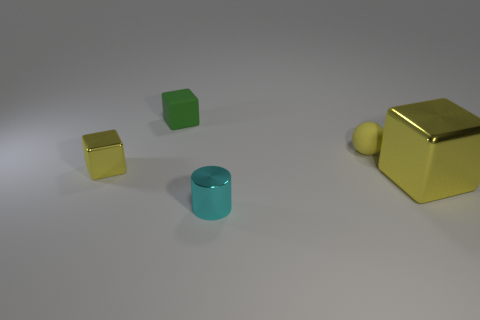Are there any small yellow balls behind the yellow sphere?
Your answer should be very brief. No. How many green objects are the same shape as the small yellow metallic thing?
Offer a very short reply. 1. There is a tiny metal thing left of the tiny object in front of the yellow shiny cube that is to the right of the green object; what is its color?
Your answer should be compact. Yellow. Does the small yellow object that is right of the small cyan shiny thing have the same material as the small block in front of the sphere?
Make the answer very short. No. What number of things are either objects behind the cylinder or tiny matte blocks?
Your answer should be very brief. 4. How many objects are tiny metallic objects or blocks that are to the right of the small shiny cube?
Your answer should be compact. 4. How many metallic spheres are the same size as the green thing?
Offer a terse response. 0. Are there fewer small matte cubes behind the small green object than small matte blocks that are to the right of the yellow rubber ball?
Keep it short and to the point. No. What number of metallic objects are large yellow objects or tiny yellow cylinders?
Offer a very short reply. 1. There is a large yellow thing; what shape is it?
Keep it short and to the point. Cube. 